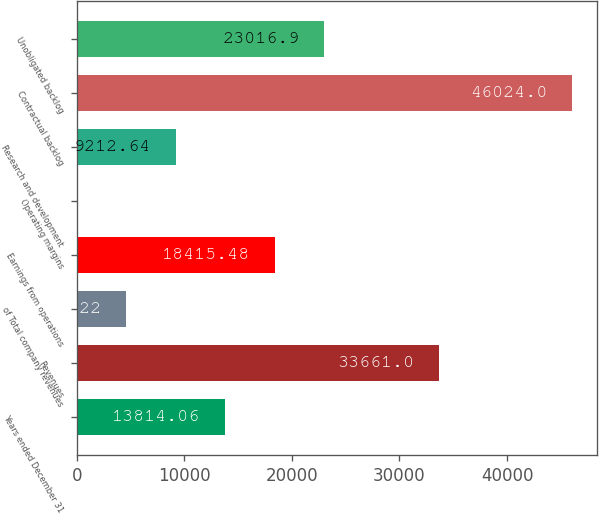Convert chart to OTSL. <chart><loc_0><loc_0><loc_500><loc_500><bar_chart><fcel>Years ended December 31<fcel>Revenues<fcel>of Total company revenues<fcel>Earnings from operations<fcel>Operating margins<fcel>Research and development<fcel>Contractual backlog<fcel>Unobligated backlog<nl><fcel>13814.1<fcel>33661<fcel>4611.22<fcel>18415.5<fcel>9.8<fcel>9212.64<fcel>46024<fcel>23016.9<nl></chart> 